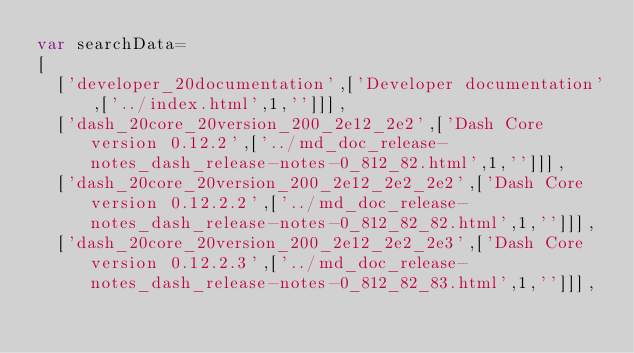Convert code to text. <code><loc_0><loc_0><loc_500><loc_500><_JavaScript_>var searchData=
[
  ['developer_20documentation',['Developer documentation',['../index.html',1,'']]],
  ['dash_20core_20version_200_2e12_2e2',['Dash Core version 0.12.2',['../md_doc_release-notes_dash_release-notes-0_812_82.html',1,'']]],
  ['dash_20core_20version_200_2e12_2e2_2e2',['Dash Core version 0.12.2.2',['../md_doc_release-notes_dash_release-notes-0_812_82_82.html',1,'']]],
  ['dash_20core_20version_200_2e12_2e2_2e3',['Dash Core version 0.12.2.3',['../md_doc_release-notes_dash_release-notes-0_812_82_83.html',1,'']]],</code> 